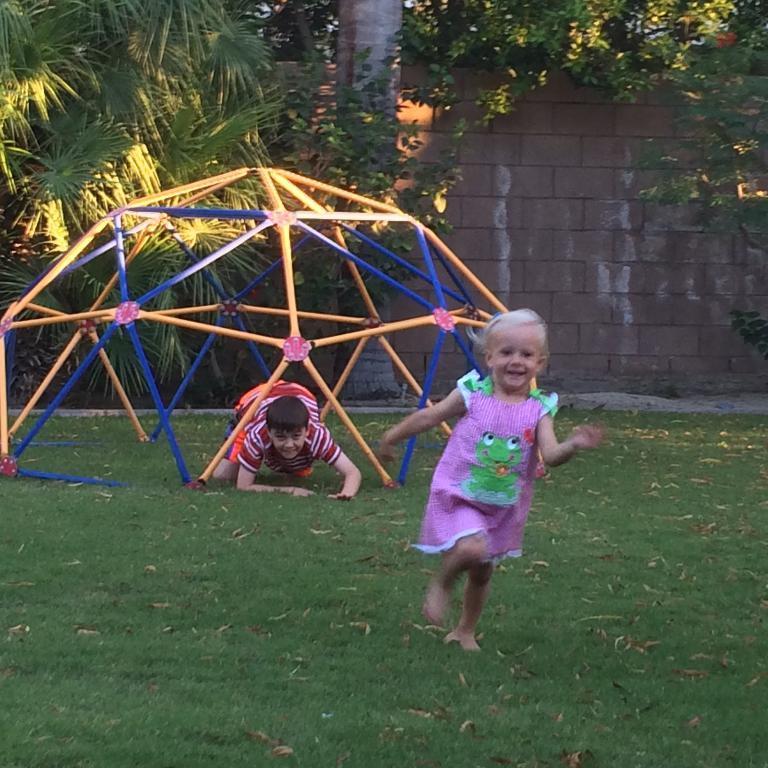Please provide a concise description of this image. In the image there is a garden and there is a baby running on the grass and behind the baby there is some playing object made up of rods and a boy is in a crawling position under the rods, in the background there is a wall and around the wall there are trees. 